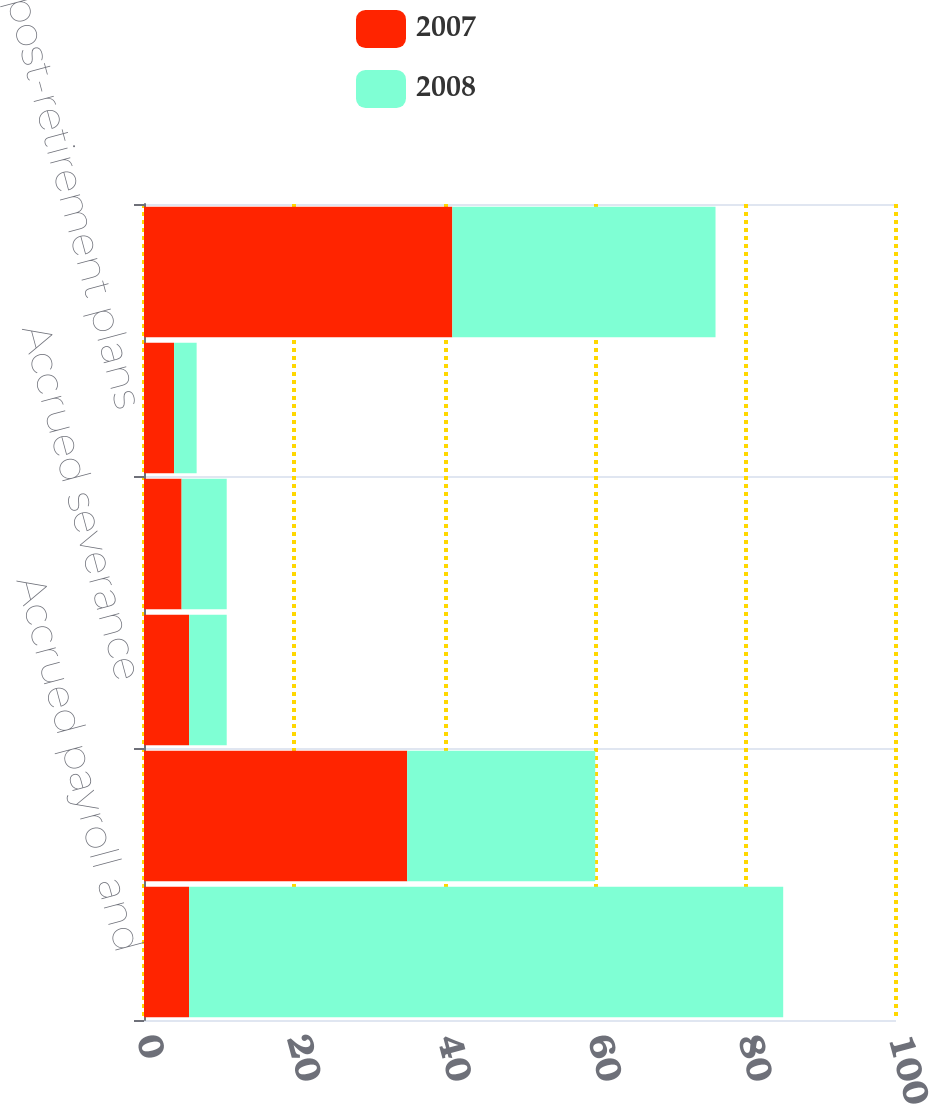Convert chart. <chart><loc_0><loc_0><loc_500><loc_500><stacked_bar_chart><ecel><fcel>Accrued payroll and<fcel>Peruvian workers'<fcel>Accrued severance<fcel>Employee pension benefits<fcel>Other post-retirement plans<fcel>Other employee-related<nl><fcel>2007<fcel>6<fcel>35<fcel>6<fcel>5<fcel>4<fcel>41<nl><fcel>2008<fcel>79<fcel>25<fcel>5<fcel>6<fcel>3<fcel>35<nl></chart> 